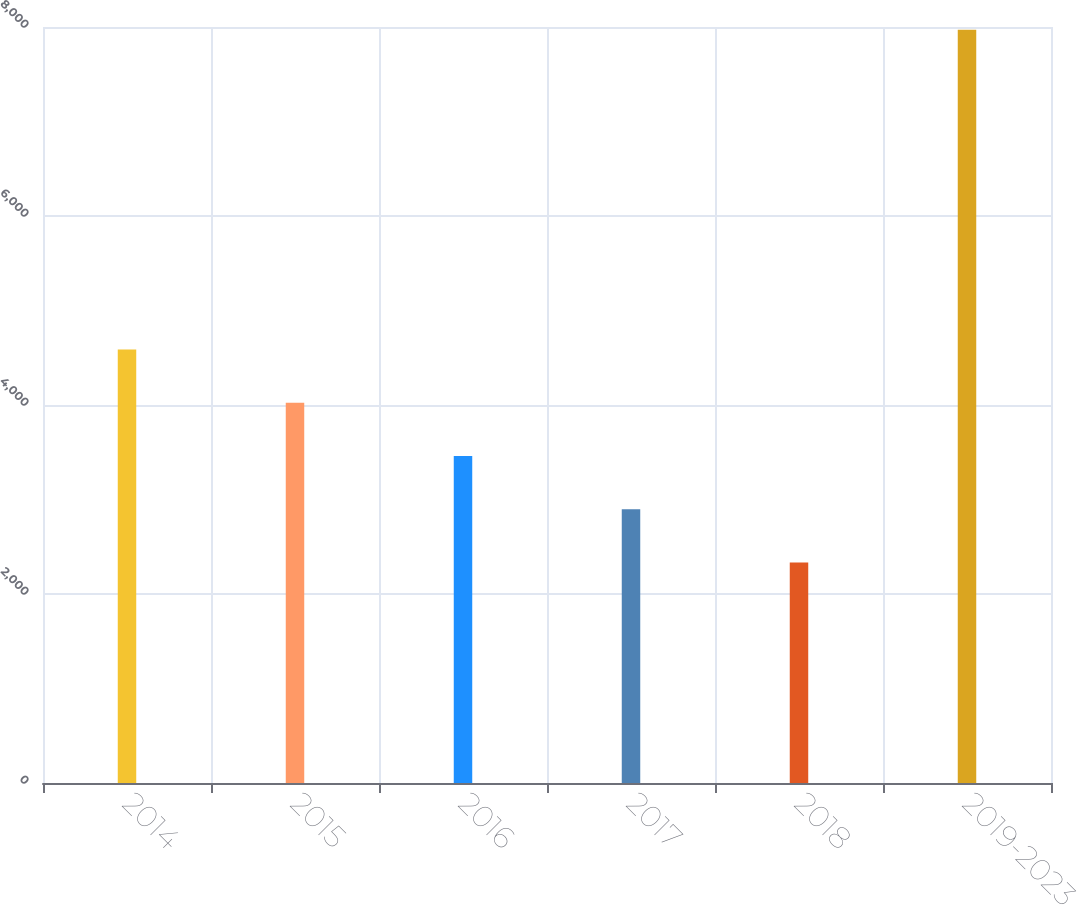Convert chart to OTSL. <chart><loc_0><loc_0><loc_500><loc_500><bar_chart><fcel>2014<fcel>2015<fcel>2016<fcel>2017<fcel>2018<fcel>2019-2023<nl><fcel>4588.4<fcel>4024.8<fcel>3461.2<fcel>2897.6<fcel>2334<fcel>7970<nl></chart> 